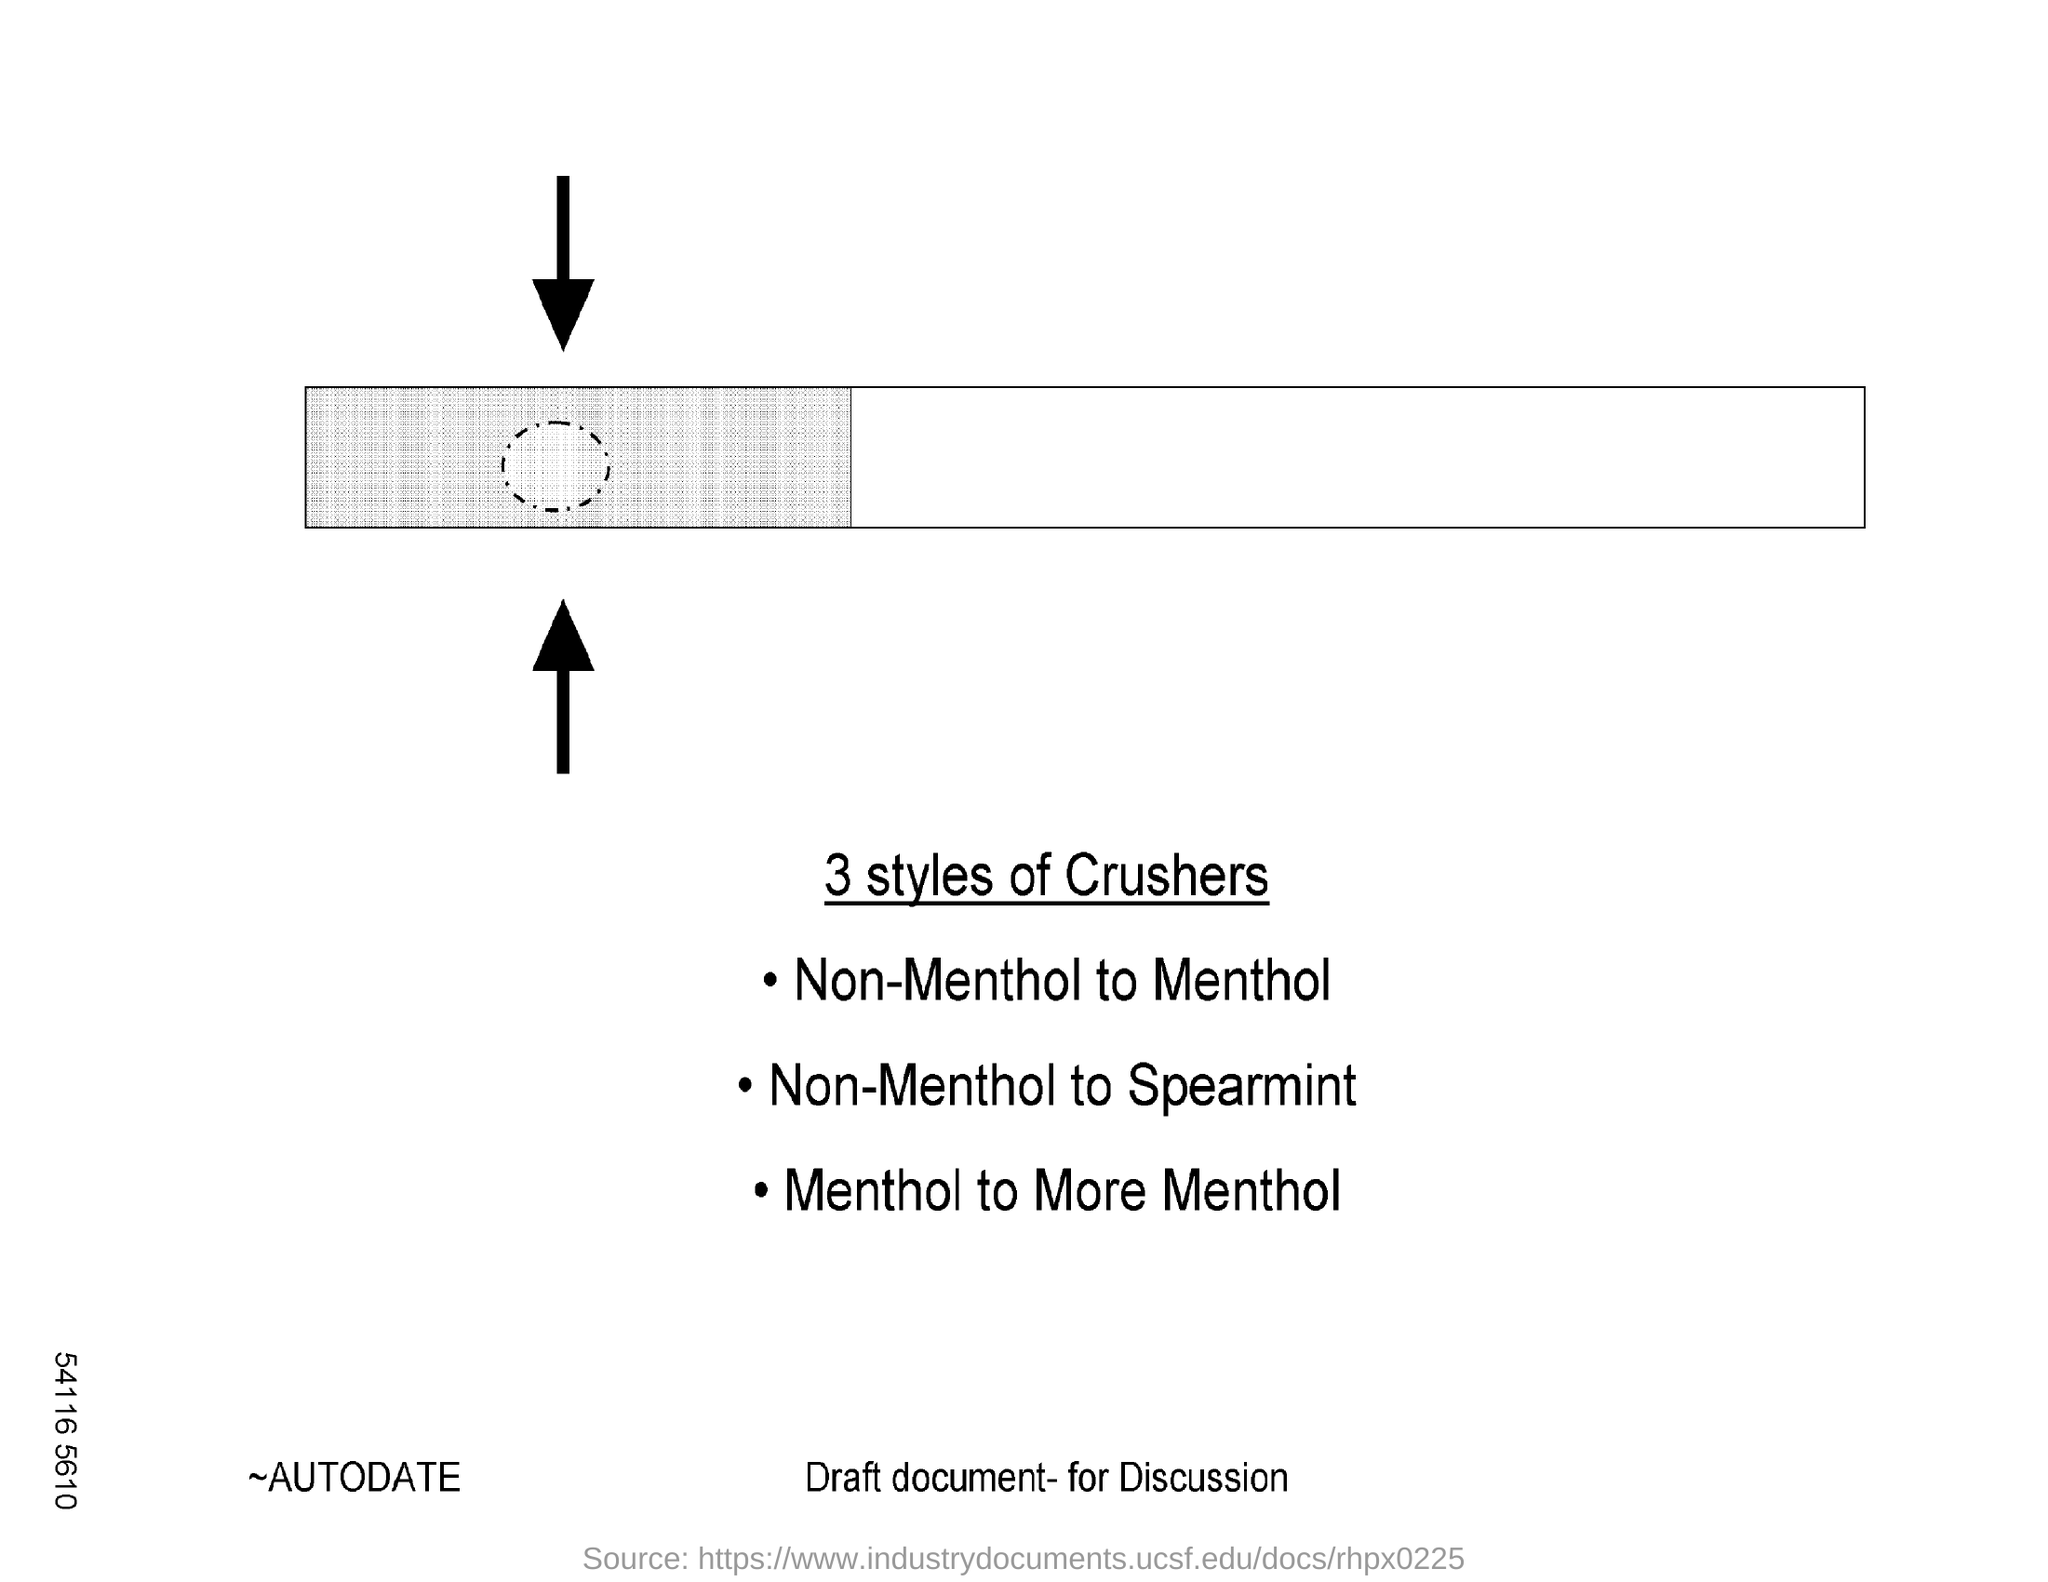What is the first style of crusher?
Give a very brief answer. Non-Menthol to Menthol. What is the second style of crusher?
Your answer should be very brief. Non-Menthol to Spearmint. What is the third style of crusher?
Give a very brief answer. Menthol to more menthol. 